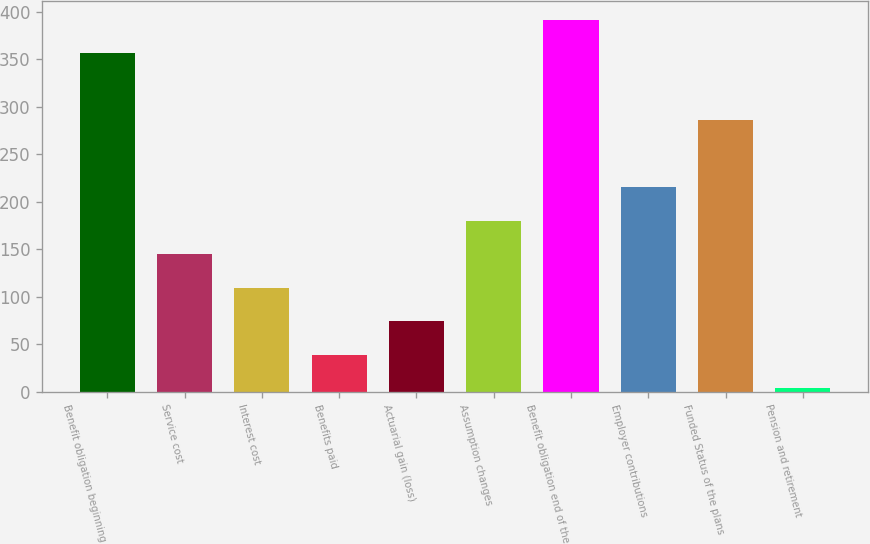<chart> <loc_0><loc_0><loc_500><loc_500><bar_chart><fcel>Benefit obligation beginning<fcel>Service cost<fcel>Interest cost<fcel>Benefits paid<fcel>Actuarial gain (loss)<fcel>Assumption changes<fcel>Benefit obligation end of the<fcel>Employer contributions<fcel>Funded Status of the plans<fcel>Pension and retirement<nl><fcel>356.3<fcel>144.68<fcel>109.41<fcel>38.87<fcel>74.14<fcel>179.95<fcel>391.57<fcel>215.22<fcel>285.76<fcel>3.6<nl></chart> 